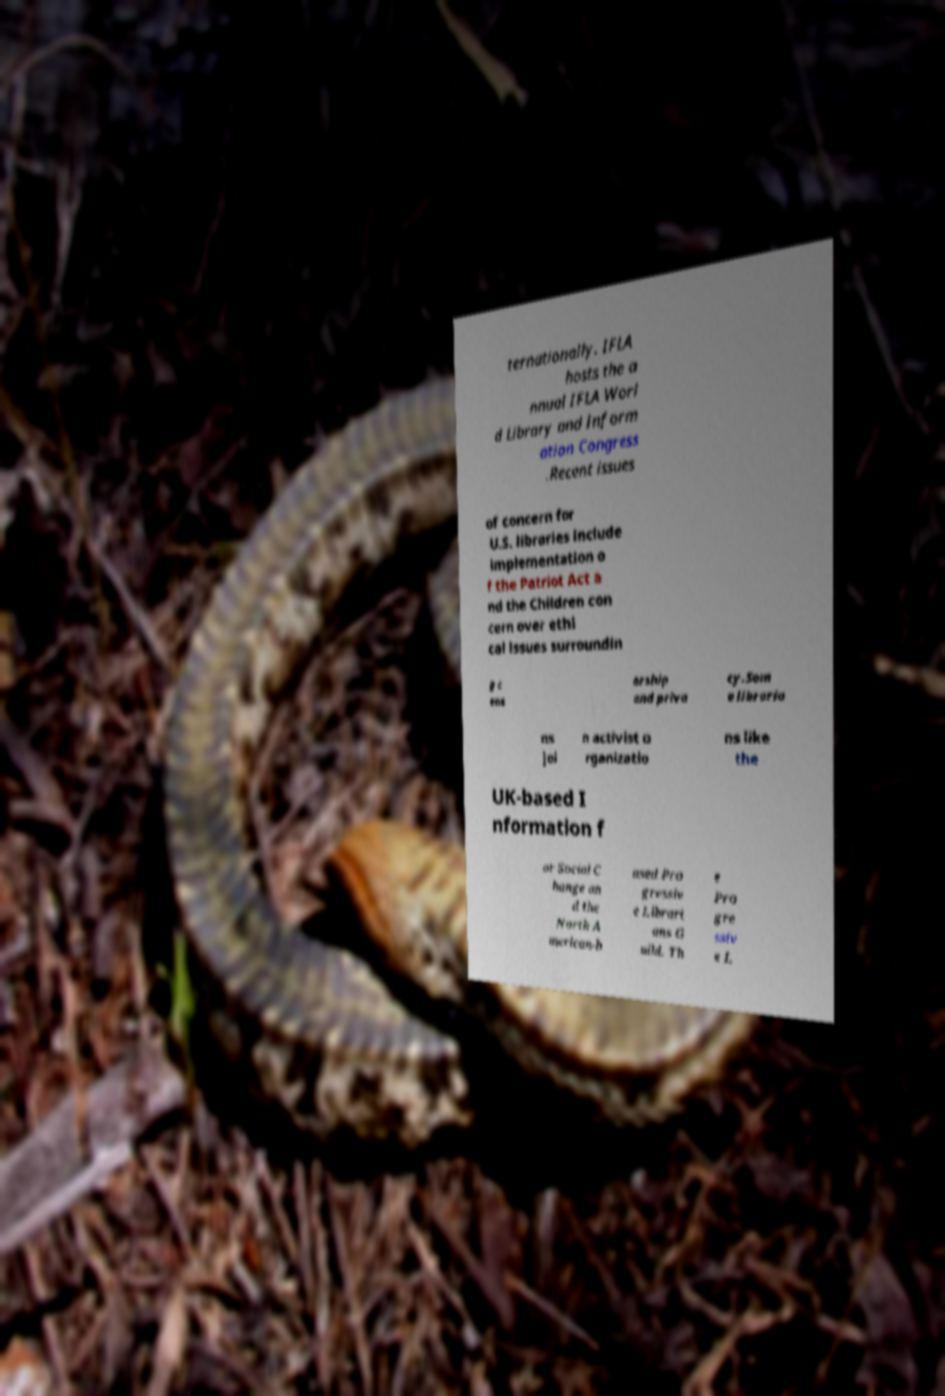What messages or text are displayed in this image? I need them in a readable, typed format. ternationally. IFLA hosts the a nnual IFLA Worl d Library and Inform ation Congress .Recent issues of concern for U.S. libraries include implementation o f the Patriot Act a nd the Children con cern over ethi cal issues surroundin g c ens orship and priva cy.Som e libraria ns joi n activist o rganizatio ns like the UK-based I nformation f or Social C hange an d the North A merican-b ased Pro gressiv e Librari ans G uild. Th e Pro gre ssiv e L 